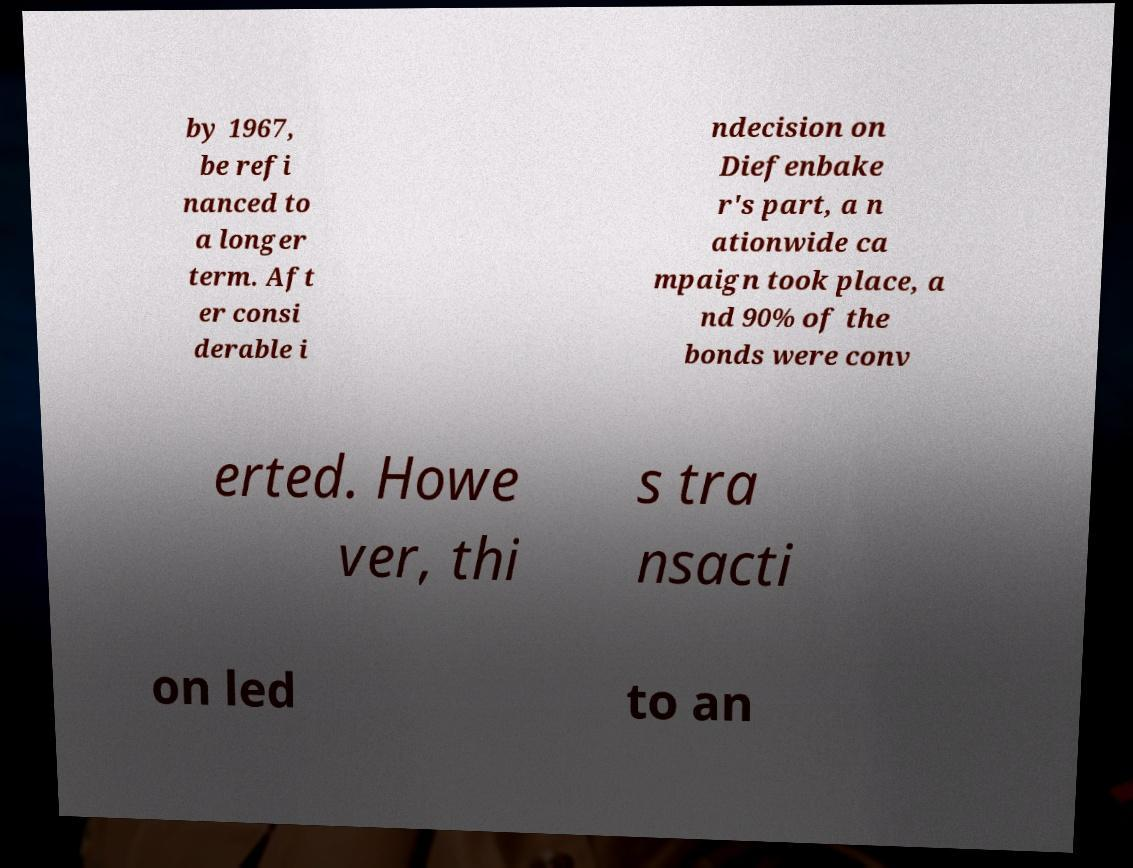There's text embedded in this image that I need extracted. Can you transcribe it verbatim? by 1967, be refi nanced to a longer term. Aft er consi derable i ndecision on Diefenbake r's part, a n ationwide ca mpaign took place, a nd 90% of the bonds were conv erted. Howe ver, thi s tra nsacti on led to an 